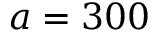<formula> <loc_0><loc_0><loc_500><loc_500>a = 3 0 0</formula> 